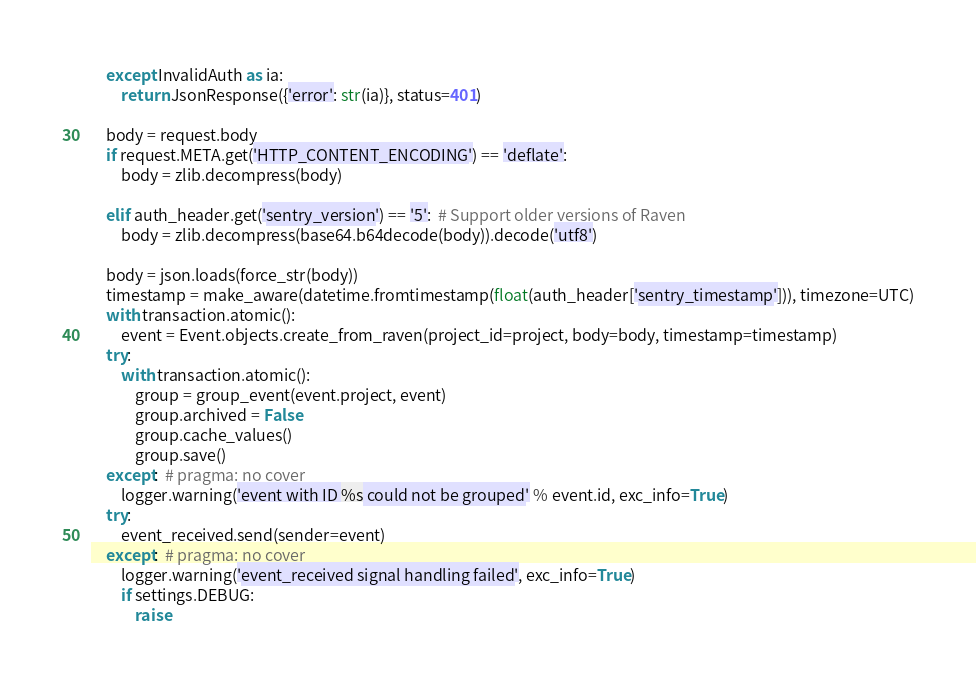<code> <loc_0><loc_0><loc_500><loc_500><_Python_>    except InvalidAuth as ia:
        return JsonResponse({'error': str(ia)}, status=401)

    body = request.body
    if request.META.get('HTTP_CONTENT_ENCODING') == 'deflate':
        body = zlib.decompress(body)

    elif auth_header.get('sentry_version') == '5':  # Support older versions of Raven
        body = zlib.decompress(base64.b64decode(body)).decode('utf8')

    body = json.loads(force_str(body))
    timestamp = make_aware(datetime.fromtimestamp(float(auth_header['sentry_timestamp'])), timezone=UTC)
    with transaction.atomic():
        event = Event.objects.create_from_raven(project_id=project, body=body, timestamp=timestamp)
    try:
        with transaction.atomic():
            group = group_event(event.project, event)
            group.archived = False
            group.cache_values()
            group.save()
    except:  # pragma: no cover
        logger.warning('event with ID %s could not be grouped' % event.id, exc_info=True)
    try:
        event_received.send(sender=event)
    except:  # pragma: no cover
        logger.warning('event_received signal handling failed', exc_info=True)
        if settings.DEBUG:
            raise</code> 